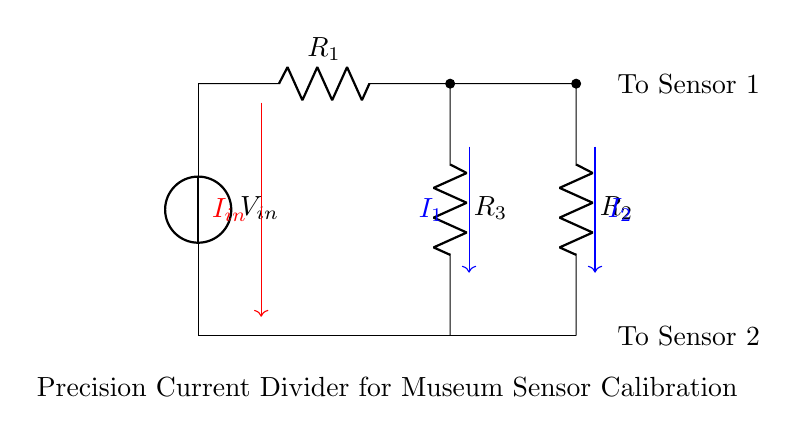What is the input voltage of this circuit? The input voltage is labeled as V_in, which is the designated source of voltage for the circuit.
Answer: V_in What are the resistors used in the circuit? The circuit contains three resistors labeled R_1, R_2, and R_3, which are used to divide the current.
Answer: R_1, R_2, R_3 What is the total current entering the circuit? The total current entering the circuit is represented by I_in, depicted by the red arrow pointing down into the circuit from the input source.
Answer: I_in How is the current divided in this circuit? The current is divided based on the resistances of R_1, R_2, and R_3 in accordance with the current divider rule, which states that the current divides inversely to the resistance values.
Answer: Inversely to resistance values If R_1 is twice the value of R_2, what is the ratio of current I_1 to current I_2? Since I_1 and I_2 will divide the input current in a ratio that inversely corresponds to the resistors, and given R_1 = 2 * R_2, the ratio I_1/I_2 will be 1/2.
Answer: 1/2 